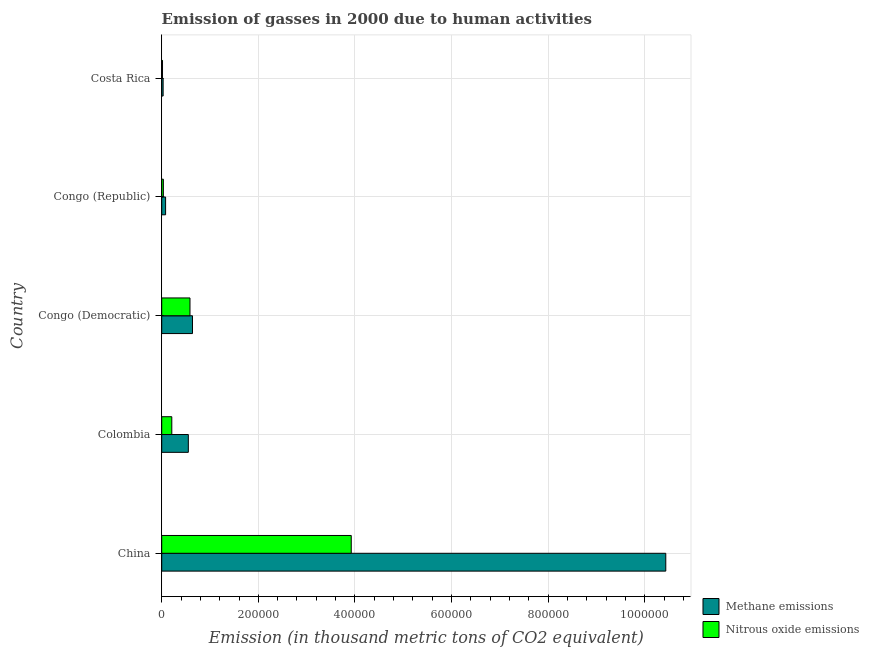How many bars are there on the 5th tick from the top?
Your answer should be compact. 2. What is the label of the 1st group of bars from the top?
Offer a terse response. Costa Rica. In how many cases, is the number of bars for a given country not equal to the number of legend labels?
Your answer should be compact. 0. What is the amount of nitrous oxide emissions in China?
Keep it short and to the point. 3.92e+05. Across all countries, what is the maximum amount of nitrous oxide emissions?
Your answer should be very brief. 3.92e+05. Across all countries, what is the minimum amount of methane emissions?
Your answer should be very brief. 2916.9. In which country was the amount of methane emissions maximum?
Provide a short and direct response. China. What is the total amount of methane emissions in the graph?
Give a very brief answer. 1.17e+06. What is the difference between the amount of methane emissions in China and that in Congo (Democratic)?
Offer a terse response. 9.80e+05. What is the difference between the amount of methane emissions in Congo (Democratic) and the amount of nitrous oxide emissions in Congo (Republic)?
Keep it short and to the point. 6.03e+04. What is the average amount of methane emissions per country?
Offer a terse response. 2.35e+05. What is the difference between the amount of nitrous oxide emissions and amount of methane emissions in Colombia?
Provide a succinct answer. -3.42e+04. What is the ratio of the amount of methane emissions in Colombia to that in Costa Rica?
Your answer should be compact. 18.89. What is the difference between the highest and the second highest amount of nitrous oxide emissions?
Provide a short and direct response. 3.34e+05. What is the difference between the highest and the lowest amount of nitrous oxide emissions?
Keep it short and to the point. 3.91e+05. What does the 1st bar from the top in China represents?
Give a very brief answer. Nitrous oxide emissions. What does the 2nd bar from the bottom in China represents?
Ensure brevity in your answer.  Nitrous oxide emissions. How many bars are there?
Make the answer very short. 10. Are the values on the major ticks of X-axis written in scientific E-notation?
Your answer should be compact. No. Does the graph contain any zero values?
Your answer should be very brief. No. Does the graph contain grids?
Offer a very short reply. Yes. Where does the legend appear in the graph?
Provide a short and direct response. Bottom right. How many legend labels are there?
Offer a very short reply. 2. How are the legend labels stacked?
Your response must be concise. Vertical. What is the title of the graph?
Your answer should be compact. Emission of gasses in 2000 due to human activities. Does "ODA received" appear as one of the legend labels in the graph?
Give a very brief answer. No. What is the label or title of the X-axis?
Ensure brevity in your answer.  Emission (in thousand metric tons of CO2 equivalent). What is the label or title of the Y-axis?
Make the answer very short. Country. What is the Emission (in thousand metric tons of CO2 equivalent) in Methane emissions in China?
Offer a terse response. 1.04e+06. What is the Emission (in thousand metric tons of CO2 equivalent) of Nitrous oxide emissions in China?
Make the answer very short. 3.92e+05. What is the Emission (in thousand metric tons of CO2 equivalent) of Methane emissions in Colombia?
Ensure brevity in your answer.  5.51e+04. What is the Emission (in thousand metric tons of CO2 equivalent) in Nitrous oxide emissions in Colombia?
Your response must be concise. 2.09e+04. What is the Emission (in thousand metric tons of CO2 equivalent) in Methane emissions in Congo (Democratic)?
Your response must be concise. 6.37e+04. What is the Emission (in thousand metric tons of CO2 equivalent) of Nitrous oxide emissions in Congo (Democratic)?
Make the answer very short. 5.85e+04. What is the Emission (in thousand metric tons of CO2 equivalent) in Methane emissions in Congo (Republic)?
Make the answer very short. 8028.7. What is the Emission (in thousand metric tons of CO2 equivalent) of Nitrous oxide emissions in Congo (Republic)?
Make the answer very short. 3418.3. What is the Emission (in thousand metric tons of CO2 equivalent) of Methane emissions in Costa Rica?
Your response must be concise. 2916.9. What is the Emission (in thousand metric tons of CO2 equivalent) of Nitrous oxide emissions in Costa Rica?
Offer a terse response. 1653.2. Across all countries, what is the maximum Emission (in thousand metric tons of CO2 equivalent) in Methane emissions?
Offer a very short reply. 1.04e+06. Across all countries, what is the maximum Emission (in thousand metric tons of CO2 equivalent) in Nitrous oxide emissions?
Give a very brief answer. 3.92e+05. Across all countries, what is the minimum Emission (in thousand metric tons of CO2 equivalent) of Methane emissions?
Your answer should be compact. 2916.9. Across all countries, what is the minimum Emission (in thousand metric tons of CO2 equivalent) of Nitrous oxide emissions?
Your answer should be very brief. 1653.2. What is the total Emission (in thousand metric tons of CO2 equivalent) in Methane emissions in the graph?
Offer a very short reply. 1.17e+06. What is the total Emission (in thousand metric tons of CO2 equivalent) of Nitrous oxide emissions in the graph?
Offer a terse response. 4.77e+05. What is the difference between the Emission (in thousand metric tons of CO2 equivalent) of Methane emissions in China and that in Colombia?
Offer a very short reply. 9.88e+05. What is the difference between the Emission (in thousand metric tons of CO2 equivalent) of Nitrous oxide emissions in China and that in Colombia?
Your answer should be very brief. 3.71e+05. What is the difference between the Emission (in thousand metric tons of CO2 equivalent) of Methane emissions in China and that in Congo (Democratic)?
Your answer should be very brief. 9.80e+05. What is the difference between the Emission (in thousand metric tons of CO2 equivalent) of Nitrous oxide emissions in China and that in Congo (Democratic)?
Your answer should be compact. 3.34e+05. What is the difference between the Emission (in thousand metric tons of CO2 equivalent) in Methane emissions in China and that in Congo (Republic)?
Your answer should be very brief. 1.04e+06. What is the difference between the Emission (in thousand metric tons of CO2 equivalent) in Nitrous oxide emissions in China and that in Congo (Republic)?
Make the answer very short. 3.89e+05. What is the difference between the Emission (in thousand metric tons of CO2 equivalent) of Methane emissions in China and that in Costa Rica?
Make the answer very short. 1.04e+06. What is the difference between the Emission (in thousand metric tons of CO2 equivalent) of Nitrous oxide emissions in China and that in Costa Rica?
Provide a succinct answer. 3.91e+05. What is the difference between the Emission (in thousand metric tons of CO2 equivalent) of Methane emissions in Colombia and that in Congo (Democratic)?
Your answer should be very brief. -8582.2. What is the difference between the Emission (in thousand metric tons of CO2 equivalent) of Nitrous oxide emissions in Colombia and that in Congo (Democratic)?
Make the answer very short. -3.76e+04. What is the difference between the Emission (in thousand metric tons of CO2 equivalent) of Methane emissions in Colombia and that in Congo (Republic)?
Your answer should be very brief. 4.71e+04. What is the difference between the Emission (in thousand metric tons of CO2 equivalent) of Nitrous oxide emissions in Colombia and that in Congo (Republic)?
Ensure brevity in your answer.  1.75e+04. What is the difference between the Emission (in thousand metric tons of CO2 equivalent) of Methane emissions in Colombia and that in Costa Rica?
Provide a succinct answer. 5.22e+04. What is the difference between the Emission (in thousand metric tons of CO2 equivalent) in Nitrous oxide emissions in Colombia and that in Costa Rica?
Ensure brevity in your answer.  1.92e+04. What is the difference between the Emission (in thousand metric tons of CO2 equivalent) in Methane emissions in Congo (Democratic) and that in Congo (Republic)?
Provide a short and direct response. 5.57e+04. What is the difference between the Emission (in thousand metric tons of CO2 equivalent) in Nitrous oxide emissions in Congo (Democratic) and that in Congo (Republic)?
Provide a short and direct response. 5.51e+04. What is the difference between the Emission (in thousand metric tons of CO2 equivalent) in Methane emissions in Congo (Democratic) and that in Costa Rica?
Provide a short and direct response. 6.08e+04. What is the difference between the Emission (in thousand metric tons of CO2 equivalent) in Nitrous oxide emissions in Congo (Democratic) and that in Costa Rica?
Offer a terse response. 5.69e+04. What is the difference between the Emission (in thousand metric tons of CO2 equivalent) in Methane emissions in Congo (Republic) and that in Costa Rica?
Offer a terse response. 5111.8. What is the difference between the Emission (in thousand metric tons of CO2 equivalent) of Nitrous oxide emissions in Congo (Republic) and that in Costa Rica?
Your response must be concise. 1765.1. What is the difference between the Emission (in thousand metric tons of CO2 equivalent) in Methane emissions in China and the Emission (in thousand metric tons of CO2 equivalent) in Nitrous oxide emissions in Colombia?
Offer a very short reply. 1.02e+06. What is the difference between the Emission (in thousand metric tons of CO2 equivalent) of Methane emissions in China and the Emission (in thousand metric tons of CO2 equivalent) of Nitrous oxide emissions in Congo (Democratic)?
Your response must be concise. 9.85e+05. What is the difference between the Emission (in thousand metric tons of CO2 equivalent) in Methane emissions in China and the Emission (in thousand metric tons of CO2 equivalent) in Nitrous oxide emissions in Congo (Republic)?
Ensure brevity in your answer.  1.04e+06. What is the difference between the Emission (in thousand metric tons of CO2 equivalent) in Methane emissions in China and the Emission (in thousand metric tons of CO2 equivalent) in Nitrous oxide emissions in Costa Rica?
Provide a succinct answer. 1.04e+06. What is the difference between the Emission (in thousand metric tons of CO2 equivalent) in Methane emissions in Colombia and the Emission (in thousand metric tons of CO2 equivalent) in Nitrous oxide emissions in Congo (Democratic)?
Offer a terse response. -3415.1. What is the difference between the Emission (in thousand metric tons of CO2 equivalent) in Methane emissions in Colombia and the Emission (in thousand metric tons of CO2 equivalent) in Nitrous oxide emissions in Congo (Republic)?
Ensure brevity in your answer.  5.17e+04. What is the difference between the Emission (in thousand metric tons of CO2 equivalent) of Methane emissions in Colombia and the Emission (in thousand metric tons of CO2 equivalent) of Nitrous oxide emissions in Costa Rica?
Ensure brevity in your answer.  5.35e+04. What is the difference between the Emission (in thousand metric tons of CO2 equivalent) in Methane emissions in Congo (Democratic) and the Emission (in thousand metric tons of CO2 equivalent) in Nitrous oxide emissions in Congo (Republic)?
Make the answer very short. 6.03e+04. What is the difference between the Emission (in thousand metric tons of CO2 equivalent) of Methane emissions in Congo (Democratic) and the Emission (in thousand metric tons of CO2 equivalent) of Nitrous oxide emissions in Costa Rica?
Your answer should be very brief. 6.20e+04. What is the difference between the Emission (in thousand metric tons of CO2 equivalent) in Methane emissions in Congo (Republic) and the Emission (in thousand metric tons of CO2 equivalent) in Nitrous oxide emissions in Costa Rica?
Provide a short and direct response. 6375.5. What is the average Emission (in thousand metric tons of CO2 equivalent) in Methane emissions per country?
Make the answer very short. 2.35e+05. What is the average Emission (in thousand metric tons of CO2 equivalent) of Nitrous oxide emissions per country?
Provide a succinct answer. 9.54e+04. What is the difference between the Emission (in thousand metric tons of CO2 equivalent) in Methane emissions and Emission (in thousand metric tons of CO2 equivalent) in Nitrous oxide emissions in China?
Provide a succinct answer. 6.51e+05. What is the difference between the Emission (in thousand metric tons of CO2 equivalent) of Methane emissions and Emission (in thousand metric tons of CO2 equivalent) of Nitrous oxide emissions in Colombia?
Your answer should be compact. 3.42e+04. What is the difference between the Emission (in thousand metric tons of CO2 equivalent) of Methane emissions and Emission (in thousand metric tons of CO2 equivalent) of Nitrous oxide emissions in Congo (Democratic)?
Make the answer very short. 5167.1. What is the difference between the Emission (in thousand metric tons of CO2 equivalent) of Methane emissions and Emission (in thousand metric tons of CO2 equivalent) of Nitrous oxide emissions in Congo (Republic)?
Keep it short and to the point. 4610.4. What is the difference between the Emission (in thousand metric tons of CO2 equivalent) in Methane emissions and Emission (in thousand metric tons of CO2 equivalent) in Nitrous oxide emissions in Costa Rica?
Provide a short and direct response. 1263.7. What is the ratio of the Emission (in thousand metric tons of CO2 equivalent) of Methane emissions in China to that in Colombia?
Provide a succinct answer. 18.93. What is the ratio of the Emission (in thousand metric tons of CO2 equivalent) of Nitrous oxide emissions in China to that in Colombia?
Make the answer very short. 18.78. What is the ratio of the Emission (in thousand metric tons of CO2 equivalent) in Methane emissions in China to that in Congo (Democratic)?
Make the answer very short. 16.38. What is the ratio of the Emission (in thousand metric tons of CO2 equivalent) of Nitrous oxide emissions in China to that in Congo (Democratic)?
Provide a short and direct response. 6.7. What is the ratio of the Emission (in thousand metric tons of CO2 equivalent) in Methane emissions in China to that in Congo (Republic)?
Ensure brevity in your answer.  129.96. What is the ratio of the Emission (in thousand metric tons of CO2 equivalent) of Nitrous oxide emissions in China to that in Congo (Republic)?
Offer a terse response. 114.78. What is the ratio of the Emission (in thousand metric tons of CO2 equivalent) of Methane emissions in China to that in Costa Rica?
Keep it short and to the point. 357.72. What is the ratio of the Emission (in thousand metric tons of CO2 equivalent) of Nitrous oxide emissions in China to that in Costa Rica?
Keep it short and to the point. 237.34. What is the ratio of the Emission (in thousand metric tons of CO2 equivalent) in Methane emissions in Colombia to that in Congo (Democratic)?
Your answer should be very brief. 0.87. What is the ratio of the Emission (in thousand metric tons of CO2 equivalent) of Nitrous oxide emissions in Colombia to that in Congo (Democratic)?
Your answer should be compact. 0.36. What is the ratio of the Emission (in thousand metric tons of CO2 equivalent) of Methane emissions in Colombia to that in Congo (Republic)?
Offer a very short reply. 6.86. What is the ratio of the Emission (in thousand metric tons of CO2 equivalent) in Nitrous oxide emissions in Colombia to that in Congo (Republic)?
Provide a short and direct response. 6.11. What is the ratio of the Emission (in thousand metric tons of CO2 equivalent) of Methane emissions in Colombia to that in Costa Rica?
Offer a terse response. 18.89. What is the ratio of the Emission (in thousand metric tons of CO2 equivalent) of Nitrous oxide emissions in Colombia to that in Costa Rica?
Your answer should be compact. 12.64. What is the ratio of the Emission (in thousand metric tons of CO2 equivalent) in Methane emissions in Congo (Democratic) to that in Congo (Republic)?
Your answer should be very brief. 7.93. What is the ratio of the Emission (in thousand metric tons of CO2 equivalent) of Nitrous oxide emissions in Congo (Democratic) to that in Congo (Republic)?
Your answer should be compact. 17.12. What is the ratio of the Emission (in thousand metric tons of CO2 equivalent) of Methane emissions in Congo (Democratic) to that in Costa Rica?
Ensure brevity in your answer.  21.84. What is the ratio of the Emission (in thousand metric tons of CO2 equivalent) in Nitrous oxide emissions in Congo (Democratic) to that in Costa Rica?
Keep it short and to the point. 35.4. What is the ratio of the Emission (in thousand metric tons of CO2 equivalent) of Methane emissions in Congo (Republic) to that in Costa Rica?
Keep it short and to the point. 2.75. What is the ratio of the Emission (in thousand metric tons of CO2 equivalent) in Nitrous oxide emissions in Congo (Republic) to that in Costa Rica?
Provide a succinct answer. 2.07. What is the difference between the highest and the second highest Emission (in thousand metric tons of CO2 equivalent) in Methane emissions?
Offer a terse response. 9.80e+05. What is the difference between the highest and the second highest Emission (in thousand metric tons of CO2 equivalent) in Nitrous oxide emissions?
Offer a terse response. 3.34e+05. What is the difference between the highest and the lowest Emission (in thousand metric tons of CO2 equivalent) of Methane emissions?
Offer a very short reply. 1.04e+06. What is the difference between the highest and the lowest Emission (in thousand metric tons of CO2 equivalent) of Nitrous oxide emissions?
Your answer should be very brief. 3.91e+05. 